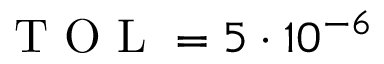<formula> <loc_0><loc_0><loc_500><loc_500>T O L = 5 \cdot 1 0 ^ { - 6 }</formula> 